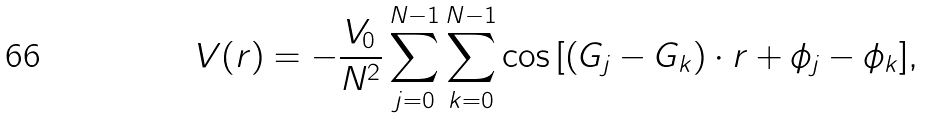<formula> <loc_0><loc_0><loc_500><loc_500>V ( r ) = - \frac { V _ { 0 } } { N ^ { 2 } } \sum _ { j = 0 } ^ { N - 1 } \sum _ { k = 0 } ^ { N - 1 } { \cos \left [ \left ( G _ { j } - G _ { k } \right ) \cdot r + \phi _ { j } - \phi _ { k } \right ] } ,</formula> 